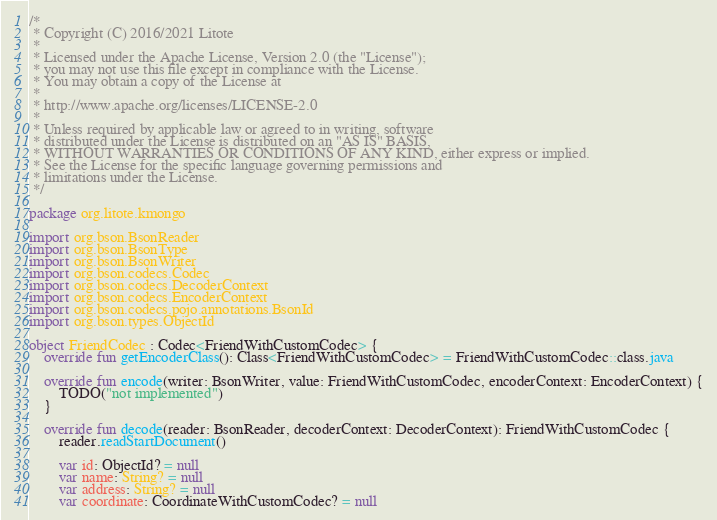Convert code to text. <code><loc_0><loc_0><loc_500><loc_500><_Kotlin_>/*
 * Copyright (C) 2016/2021 Litote
 *
 * Licensed under the Apache License, Version 2.0 (the "License");
 * you may not use this file except in compliance with the License.
 * You may obtain a copy of the License at
 *
 * http://www.apache.org/licenses/LICENSE-2.0
 *
 * Unless required by applicable law or agreed to in writing, software
 * distributed under the License is distributed on an "AS IS" BASIS,
 * WITHOUT WARRANTIES OR CONDITIONS OF ANY KIND, either express or implied.
 * See the License for the specific language governing permissions and
 * limitations under the License.
 */

package org.litote.kmongo

import org.bson.BsonReader
import org.bson.BsonType
import org.bson.BsonWriter
import org.bson.codecs.Codec
import org.bson.codecs.DecoderContext
import org.bson.codecs.EncoderContext
import org.bson.codecs.pojo.annotations.BsonId
import org.bson.types.ObjectId

object FriendCodec : Codec<FriendWithCustomCodec> {
    override fun getEncoderClass(): Class<FriendWithCustomCodec> = FriendWithCustomCodec::class.java

    override fun encode(writer: BsonWriter, value: FriendWithCustomCodec, encoderContext: EncoderContext) {
        TODO("not implemented")
    }

    override fun decode(reader: BsonReader, decoderContext: DecoderContext): FriendWithCustomCodec {
        reader.readStartDocument()

        var id: ObjectId? = null
        var name: String? = null
        var address: String? = null
        var coordinate: CoordinateWithCustomCodec? = null</code> 